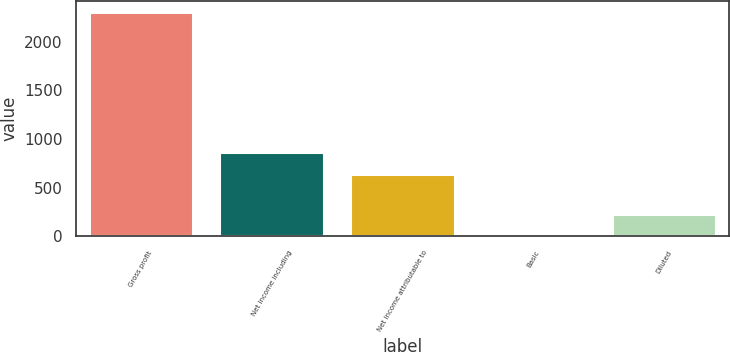Convert chart. <chart><loc_0><loc_0><loc_500><loc_500><bar_chart><fcel>Gross profit<fcel>Net income including<fcel>Net income attributable to<fcel>Basic<fcel>Diluted<nl><fcel>2301<fcel>867.03<fcel>637<fcel>0.73<fcel>230.76<nl></chart> 